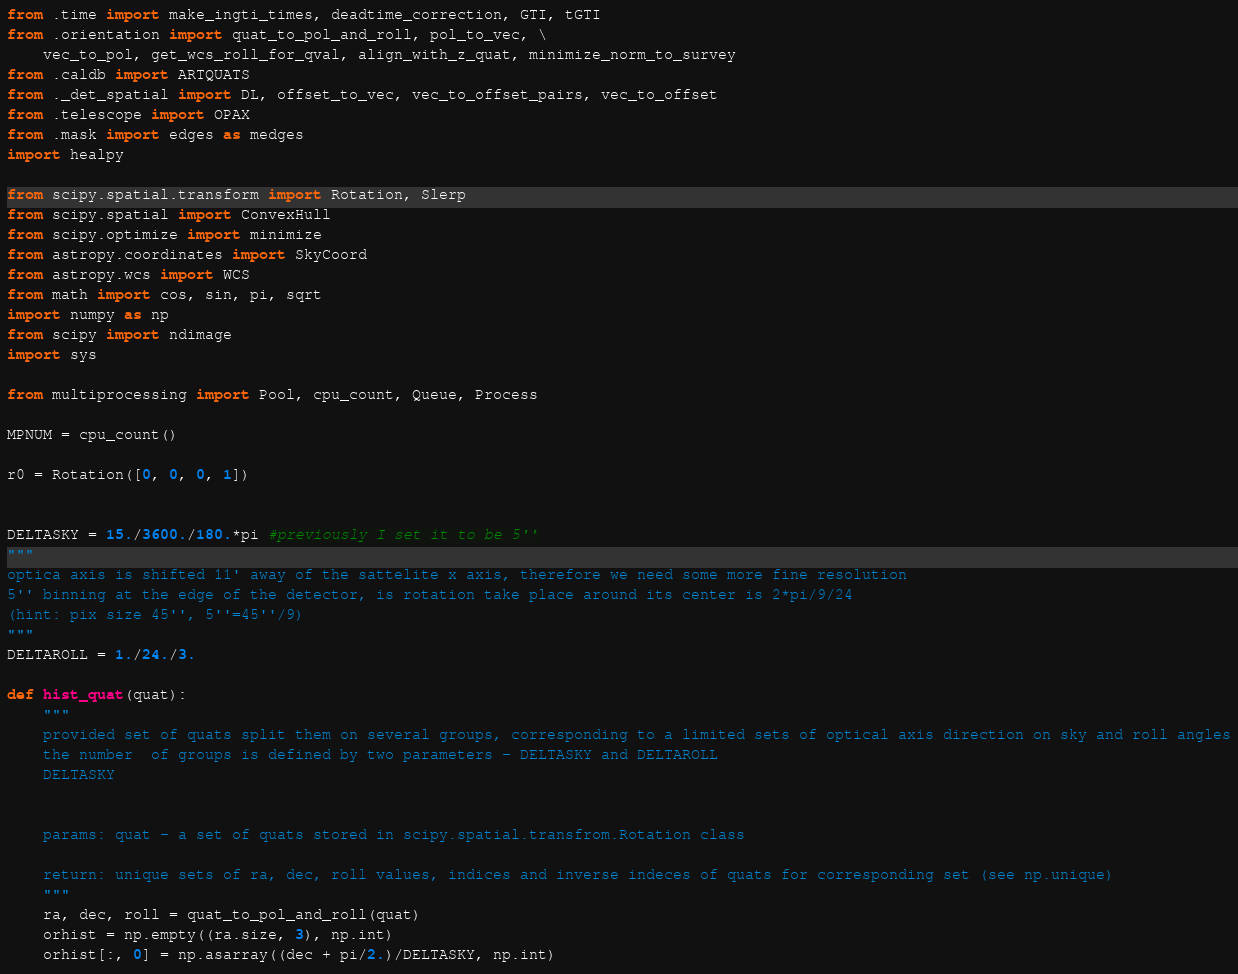Convert code to text. <code><loc_0><loc_0><loc_500><loc_500><_Python_>from .time import make_ingti_times, deadtime_correction, GTI, tGTI
from .orientation import quat_to_pol_and_roll, pol_to_vec, \
    vec_to_pol, get_wcs_roll_for_qval, align_with_z_quat, minimize_norm_to_survey
from .caldb import ARTQUATS
from ._det_spatial import DL, offset_to_vec, vec_to_offset_pairs, vec_to_offset
from .telescope import OPAX
from .mask import edges as medges
import healpy

from scipy.spatial.transform import Rotation, Slerp
from scipy.spatial import ConvexHull
from scipy.optimize import minimize
from astropy.coordinates import SkyCoord
from astropy.wcs import WCS
from math import cos, sin, pi, sqrt
import numpy as np
from scipy import ndimage
import sys

from multiprocessing import Pool, cpu_count, Queue, Process

MPNUM = cpu_count()

r0 = Rotation([0, 0, 0, 1])


DELTASKY = 15./3600./180.*pi #previously I set it to be 5''
"""
optica axis is shifted 11' away of the sattelite x axis, therefore we need some more fine resolution
5'' binning at the edge of the detector, is rotation take place around its center is 2*pi/9/24
(hint: pix size 45'', 5''=45''/9)
"""
DELTAROLL = 1./24./3.

def hist_quat(quat):
    """
    provided set of quats split them on several groups, corresponding to a limited sets of optical axis direction on sky and roll angles
    the number  of groups is defined by two parameters - DELTASKY and DELTAROLL
    DELTASKY


    params: quat - a set of quats stored in scipy.spatial.transfrom.Rotation class

    return: unique sets of ra, dec, roll values, indices and inverse indeces of quats for corresponding set (see np.unique)
    """
    ra, dec, roll = quat_to_pol_and_roll(quat)
    orhist = np.empty((ra.size, 3), np.int)
    orhist[:, 0] = np.asarray((dec + pi/2.)/DELTASKY, np.int)</code> 